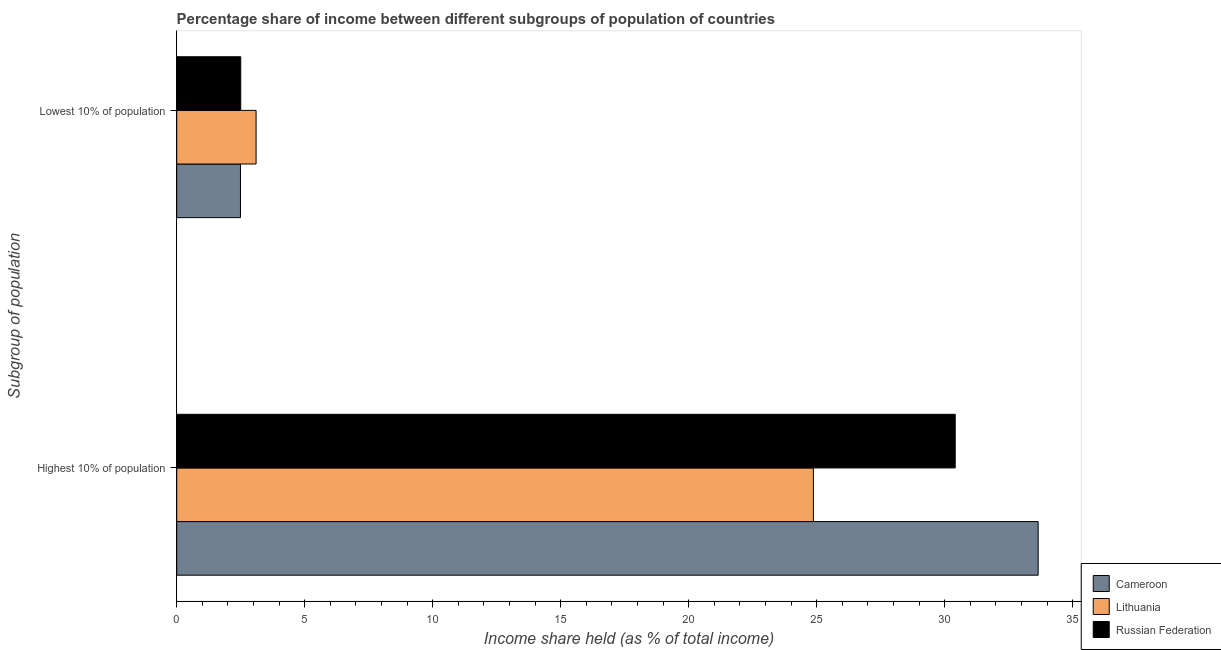How many groups of bars are there?
Keep it short and to the point. 2. Are the number of bars on each tick of the Y-axis equal?
Make the answer very short. Yes. How many bars are there on the 2nd tick from the top?
Offer a terse response. 3. What is the label of the 2nd group of bars from the top?
Offer a terse response. Highest 10% of population. What is the income share held by highest 10% of the population in Lithuania?
Your answer should be very brief. 24.87. Across all countries, what is the maximum income share held by highest 10% of the population?
Make the answer very short. 33.65. Across all countries, what is the minimum income share held by highest 10% of the population?
Your answer should be compact. 24.87. In which country was the income share held by lowest 10% of the population maximum?
Provide a short and direct response. Lithuania. In which country was the income share held by lowest 10% of the population minimum?
Your answer should be very brief. Cameroon. What is the total income share held by highest 10% of the population in the graph?
Ensure brevity in your answer.  88.93. What is the difference between the income share held by highest 10% of the population in Lithuania and that in Russian Federation?
Offer a terse response. -5.54. What is the difference between the income share held by highest 10% of the population in Lithuania and the income share held by lowest 10% of the population in Cameroon?
Give a very brief answer. 22.38. What is the average income share held by lowest 10% of the population per country?
Ensure brevity in your answer.  2.7. What is the difference between the income share held by highest 10% of the population and income share held by lowest 10% of the population in Russian Federation?
Offer a very short reply. 27.91. What is the ratio of the income share held by highest 10% of the population in Cameroon to that in Lithuania?
Your answer should be compact. 1.35. In how many countries, is the income share held by highest 10% of the population greater than the average income share held by highest 10% of the population taken over all countries?
Provide a succinct answer. 2. What does the 3rd bar from the top in Highest 10% of population represents?
Offer a terse response. Cameroon. What does the 1st bar from the bottom in Highest 10% of population represents?
Your response must be concise. Cameroon. How many bars are there?
Offer a terse response. 6. What is the difference between two consecutive major ticks on the X-axis?
Provide a short and direct response. 5. Are the values on the major ticks of X-axis written in scientific E-notation?
Offer a very short reply. No. How many legend labels are there?
Your response must be concise. 3. How are the legend labels stacked?
Offer a very short reply. Vertical. What is the title of the graph?
Your answer should be very brief. Percentage share of income between different subgroups of population of countries. Does "Cayman Islands" appear as one of the legend labels in the graph?
Ensure brevity in your answer.  No. What is the label or title of the X-axis?
Your answer should be compact. Income share held (as % of total income). What is the label or title of the Y-axis?
Ensure brevity in your answer.  Subgroup of population. What is the Income share held (as % of total income) of Cameroon in Highest 10% of population?
Give a very brief answer. 33.65. What is the Income share held (as % of total income) in Lithuania in Highest 10% of population?
Your response must be concise. 24.87. What is the Income share held (as % of total income) in Russian Federation in Highest 10% of population?
Offer a terse response. 30.41. What is the Income share held (as % of total income) of Cameroon in Lowest 10% of population?
Offer a terse response. 2.49. Across all Subgroup of population, what is the maximum Income share held (as % of total income) in Cameroon?
Provide a short and direct response. 33.65. Across all Subgroup of population, what is the maximum Income share held (as % of total income) of Lithuania?
Keep it short and to the point. 24.87. Across all Subgroup of population, what is the maximum Income share held (as % of total income) of Russian Federation?
Offer a very short reply. 30.41. Across all Subgroup of population, what is the minimum Income share held (as % of total income) in Cameroon?
Make the answer very short. 2.49. What is the total Income share held (as % of total income) in Cameroon in the graph?
Provide a short and direct response. 36.14. What is the total Income share held (as % of total income) of Lithuania in the graph?
Your answer should be compact. 27.97. What is the total Income share held (as % of total income) of Russian Federation in the graph?
Provide a short and direct response. 32.91. What is the difference between the Income share held (as % of total income) of Cameroon in Highest 10% of population and that in Lowest 10% of population?
Provide a short and direct response. 31.16. What is the difference between the Income share held (as % of total income) of Lithuania in Highest 10% of population and that in Lowest 10% of population?
Provide a succinct answer. 21.77. What is the difference between the Income share held (as % of total income) in Russian Federation in Highest 10% of population and that in Lowest 10% of population?
Your answer should be very brief. 27.91. What is the difference between the Income share held (as % of total income) in Cameroon in Highest 10% of population and the Income share held (as % of total income) in Lithuania in Lowest 10% of population?
Offer a terse response. 30.55. What is the difference between the Income share held (as % of total income) of Cameroon in Highest 10% of population and the Income share held (as % of total income) of Russian Federation in Lowest 10% of population?
Your response must be concise. 31.15. What is the difference between the Income share held (as % of total income) in Lithuania in Highest 10% of population and the Income share held (as % of total income) in Russian Federation in Lowest 10% of population?
Provide a short and direct response. 22.37. What is the average Income share held (as % of total income) of Cameroon per Subgroup of population?
Provide a succinct answer. 18.07. What is the average Income share held (as % of total income) of Lithuania per Subgroup of population?
Keep it short and to the point. 13.98. What is the average Income share held (as % of total income) of Russian Federation per Subgroup of population?
Make the answer very short. 16.45. What is the difference between the Income share held (as % of total income) of Cameroon and Income share held (as % of total income) of Lithuania in Highest 10% of population?
Make the answer very short. 8.78. What is the difference between the Income share held (as % of total income) of Cameroon and Income share held (as % of total income) of Russian Federation in Highest 10% of population?
Keep it short and to the point. 3.24. What is the difference between the Income share held (as % of total income) of Lithuania and Income share held (as % of total income) of Russian Federation in Highest 10% of population?
Offer a terse response. -5.54. What is the difference between the Income share held (as % of total income) of Cameroon and Income share held (as % of total income) of Lithuania in Lowest 10% of population?
Ensure brevity in your answer.  -0.61. What is the difference between the Income share held (as % of total income) in Cameroon and Income share held (as % of total income) in Russian Federation in Lowest 10% of population?
Provide a succinct answer. -0.01. What is the difference between the Income share held (as % of total income) of Lithuania and Income share held (as % of total income) of Russian Federation in Lowest 10% of population?
Provide a succinct answer. 0.6. What is the ratio of the Income share held (as % of total income) in Cameroon in Highest 10% of population to that in Lowest 10% of population?
Offer a terse response. 13.51. What is the ratio of the Income share held (as % of total income) of Lithuania in Highest 10% of population to that in Lowest 10% of population?
Offer a very short reply. 8.02. What is the ratio of the Income share held (as % of total income) in Russian Federation in Highest 10% of population to that in Lowest 10% of population?
Make the answer very short. 12.16. What is the difference between the highest and the second highest Income share held (as % of total income) of Cameroon?
Your answer should be compact. 31.16. What is the difference between the highest and the second highest Income share held (as % of total income) of Lithuania?
Your answer should be compact. 21.77. What is the difference between the highest and the second highest Income share held (as % of total income) in Russian Federation?
Ensure brevity in your answer.  27.91. What is the difference between the highest and the lowest Income share held (as % of total income) of Cameroon?
Provide a succinct answer. 31.16. What is the difference between the highest and the lowest Income share held (as % of total income) in Lithuania?
Make the answer very short. 21.77. What is the difference between the highest and the lowest Income share held (as % of total income) in Russian Federation?
Provide a succinct answer. 27.91. 